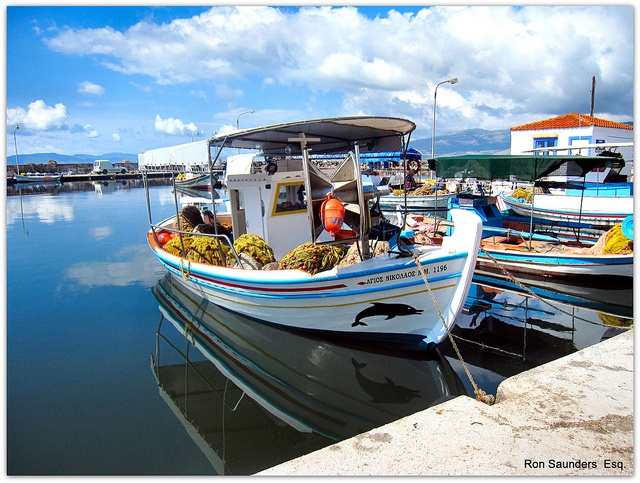Describe the objects in this image and their specific colors. I can see boat in white, darkgray, black, and gray tones, boat in white, black, ivory, gray, and blue tones, boat in white, black, cyan, and darkgray tones, boat in white, black, gray, and darkgray tones, and boat in white, gray, and darkgray tones in this image. 